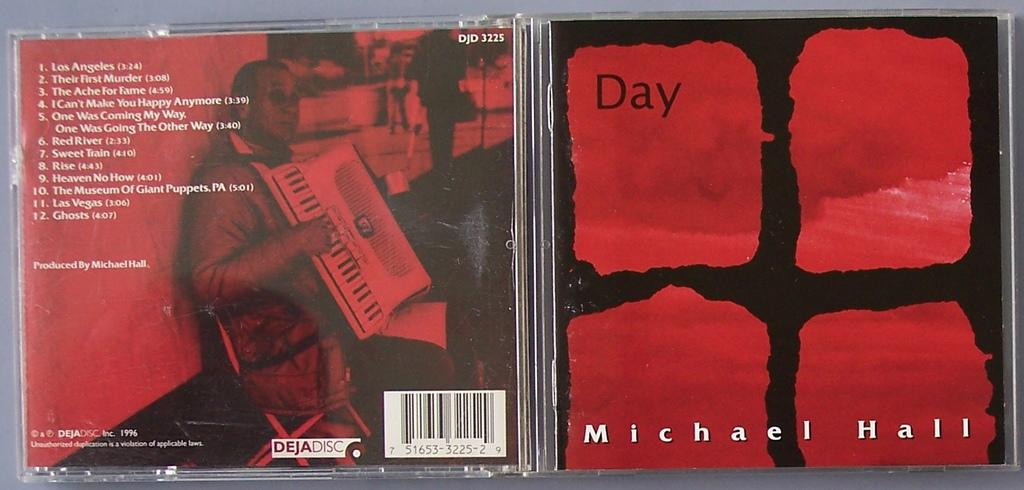<image>
Render a clear and concise summary of the photo. A CD case of Michael Halls album entitled Day. 